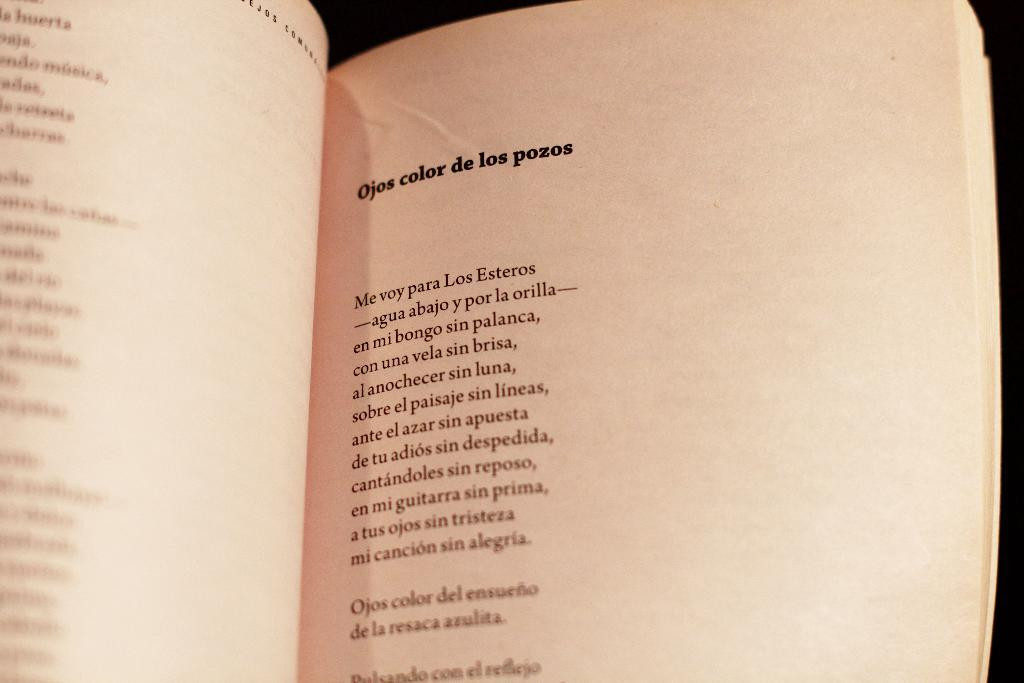<image>
Give a short and clear explanation of the subsequent image. A book opened to a poem titled, "Ojos color de los pozos" 